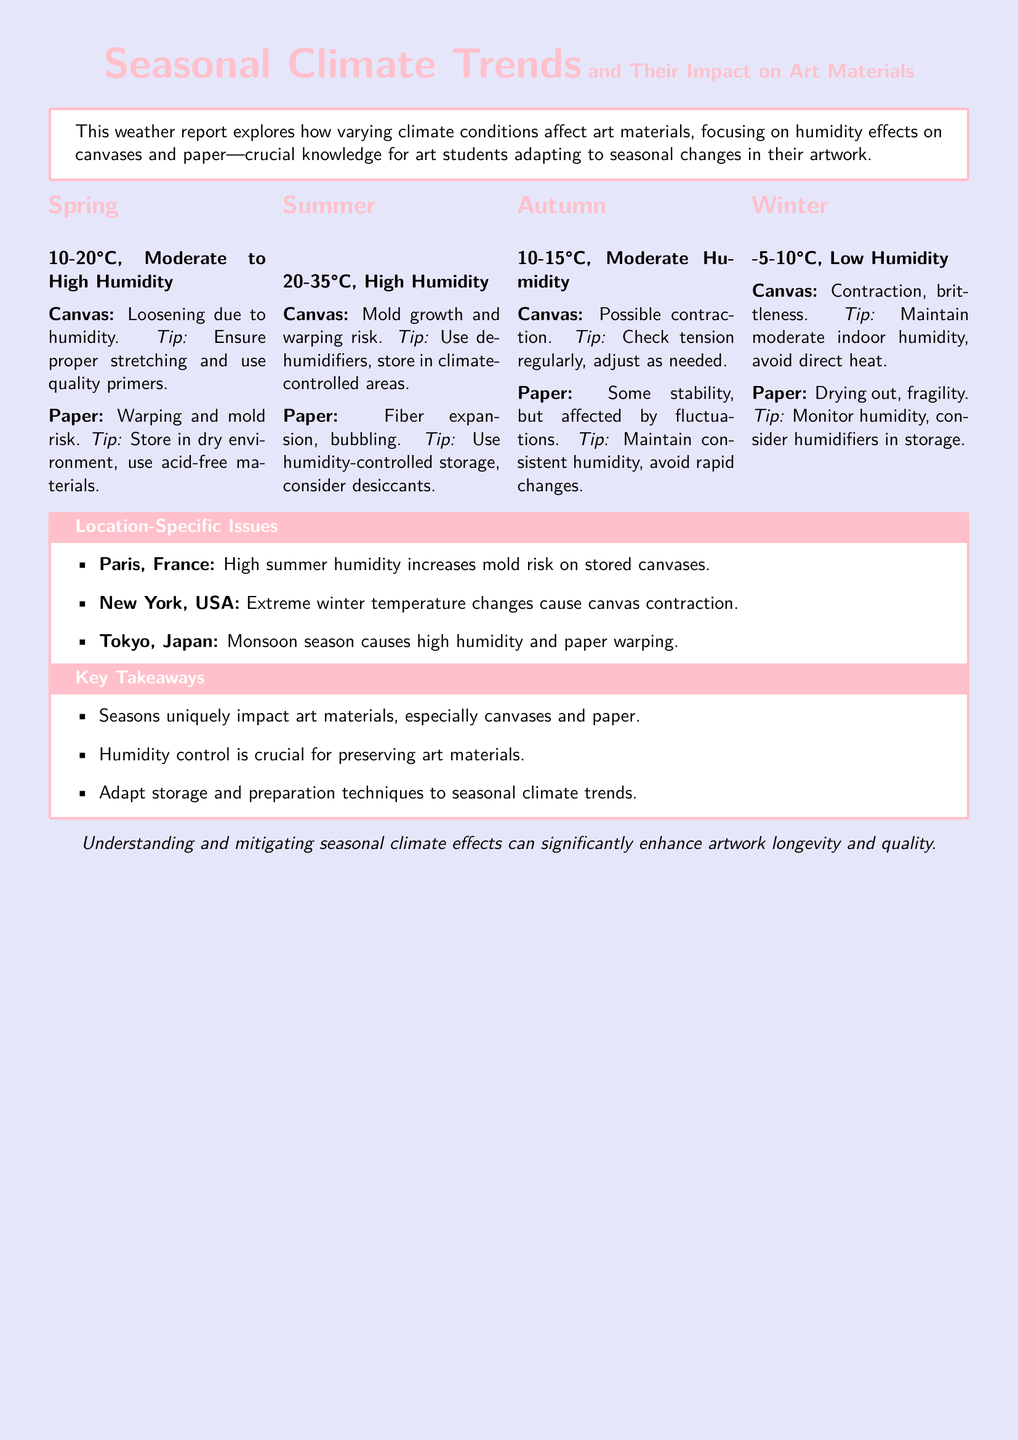What is the recommended way to handle canvases in spring? The document mentions ensuring proper stretching and using quality primers to handle canvases in spring when humidity is moderate to high.
Answer: Proper stretching and quality primers What happens to paper in summer due to humidity? High humidity in summer causes fiber expansion and bubbling in paper, according to the document.
Answer: Fiber expansion, bubbling What temperature range is mentioned for autumn? The document states that autumn has a temperature range of 10-15°C.
Answer: 10-15°C What is a potential risk for canvases in winter? The document notes that canvases are at risk of contraction and brittleness during winter due to the low humidity.
Answer: Contraction, brittleness What specific issue does humidity in Paris cause during summer? The document specifies that high summer humidity in Paris increases mold risk on stored canvases.
Answer: Increased mold risk What is the recommended action for paper during autumn? The document suggests maintaining consistent humidity and avoiding rapid changes to ensure paper stability in autumn.
Answer: Maintain consistent humidity What season has the highest humidity risk for art materials? The document identifies summer as having the highest humidity risk for art materials, specifically noting high humidity levels.
Answer: Summer What does the key takeaway emphasize about seasonal impacts? The key takeaway highlights that seasons uniquely impact art materials, especially canvases and paper.
Answer: Unique impact on art materials 